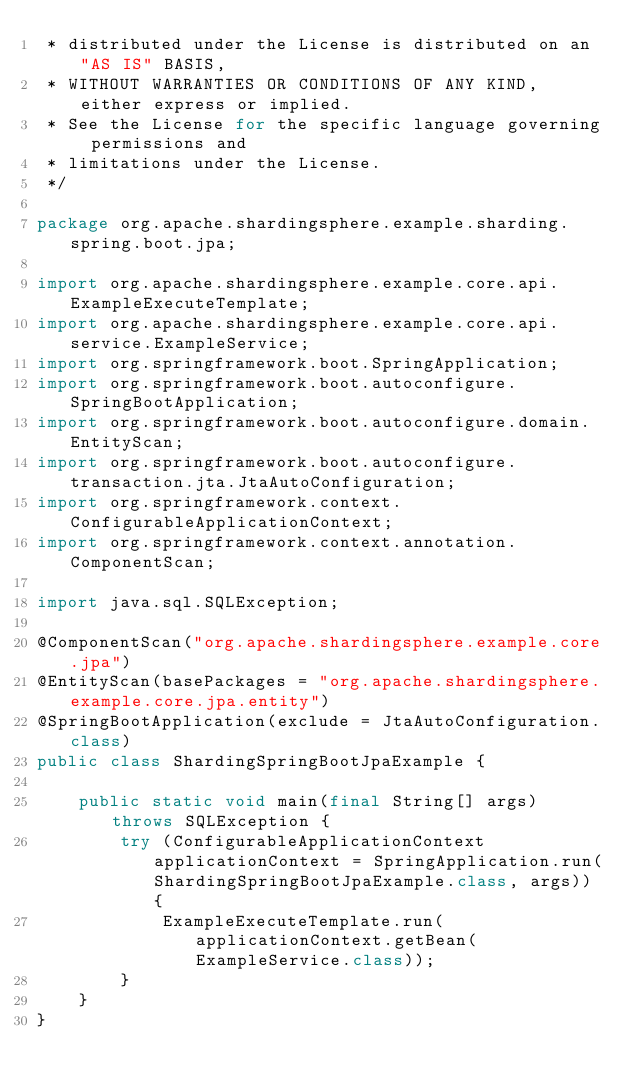<code> <loc_0><loc_0><loc_500><loc_500><_Java_> * distributed under the License is distributed on an "AS IS" BASIS,
 * WITHOUT WARRANTIES OR CONDITIONS OF ANY KIND, either express or implied.
 * See the License for the specific language governing permissions and
 * limitations under the License.
 */

package org.apache.shardingsphere.example.sharding.spring.boot.jpa;

import org.apache.shardingsphere.example.core.api.ExampleExecuteTemplate;
import org.apache.shardingsphere.example.core.api.service.ExampleService;
import org.springframework.boot.SpringApplication;
import org.springframework.boot.autoconfigure.SpringBootApplication;
import org.springframework.boot.autoconfigure.domain.EntityScan;
import org.springframework.boot.autoconfigure.transaction.jta.JtaAutoConfiguration;
import org.springframework.context.ConfigurableApplicationContext;
import org.springframework.context.annotation.ComponentScan;

import java.sql.SQLException;

@ComponentScan("org.apache.shardingsphere.example.core.jpa")
@EntityScan(basePackages = "org.apache.shardingsphere.example.core.jpa.entity")
@SpringBootApplication(exclude = JtaAutoConfiguration.class)
public class ShardingSpringBootJpaExample {
    
    public static void main(final String[] args) throws SQLException {
        try (ConfigurableApplicationContext applicationContext = SpringApplication.run(ShardingSpringBootJpaExample.class, args)) {
            ExampleExecuteTemplate.run(applicationContext.getBean(ExampleService.class));
        }
    }
}
</code> 